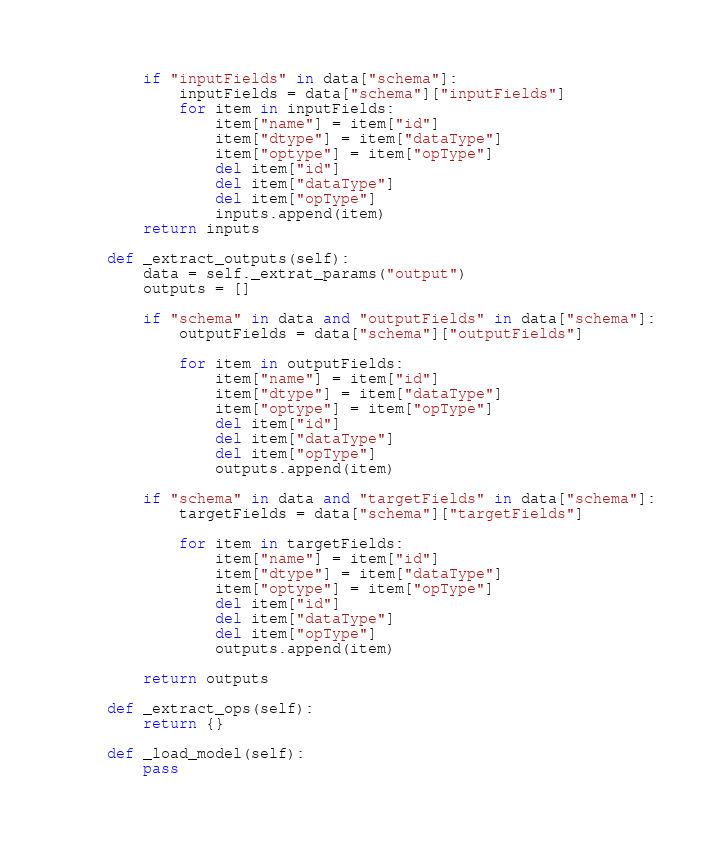Convert code to text. <code><loc_0><loc_0><loc_500><loc_500><_Python_>        if "inputFields" in data["schema"]:
            inputFields = data["schema"]["inputFields"]
            for item in inputFields:
                item["name"] = item["id"]
                item["dtype"] = item["dataType"]
                item["optype"] = item["opType"]
                del item["id"]
                del item["dataType"]
                del item["opType"]
                inputs.append(item)
        return inputs

    def _extract_outputs(self):
        data = self._extrat_params("output")
        outputs = []

        if "schema" in data and "outputFields" in data["schema"]:
            outputFields = data["schema"]["outputFields"]
        
            for item in outputFields:
                item["name"] = item["id"]
                item["dtype"] = item["dataType"]
                item["optype"] = item["opType"]
                del item["id"]
                del item["dataType"]
                del item["opType"]
                outputs.append(item)

        if "schema" in data and "targetFields" in data["schema"]:
            targetFields = data["schema"]["targetFields"]

            for item in targetFields:
                item["name"] = item["id"]
                item["dtype"] = item["dataType"]
                item["optype"] = item["opType"]
                del item["id"]
                del item["dataType"]
                del item["opType"]
                outputs.append(item)

        return outputs
    
    def _extract_ops(self):
        return {}

    def _load_model(self):
        pass</code> 